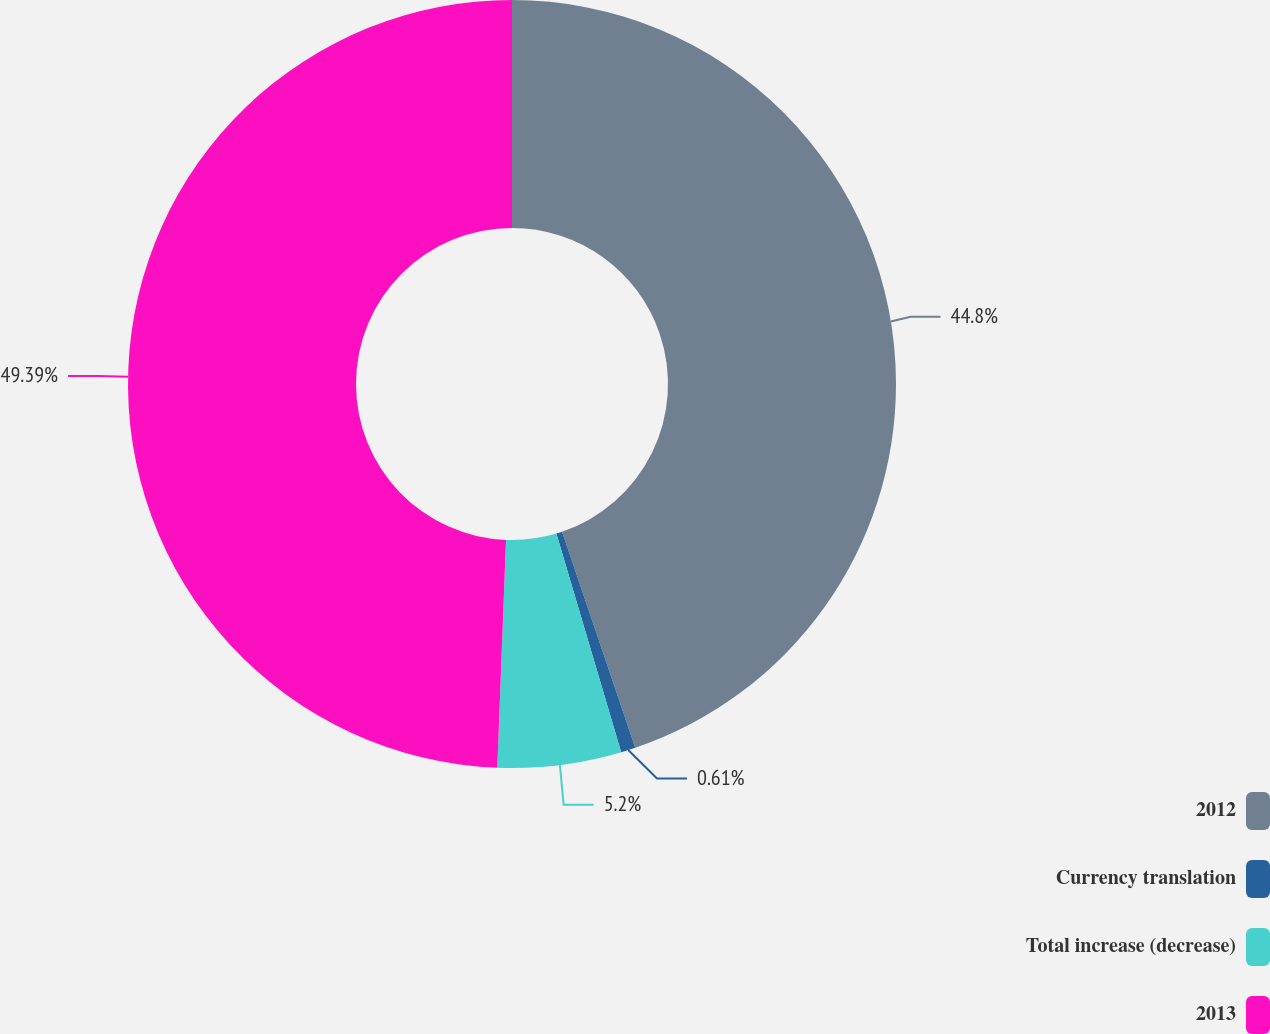Convert chart. <chart><loc_0><loc_0><loc_500><loc_500><pie_chart><fcel>2012<fcel>Currency translation<fcel>Total increase (decrease)<fcel>2013<nl><fcel>44.8%<fcel>0.61%<fcel>5.2%<fcel>49.39%<nl></chart> 